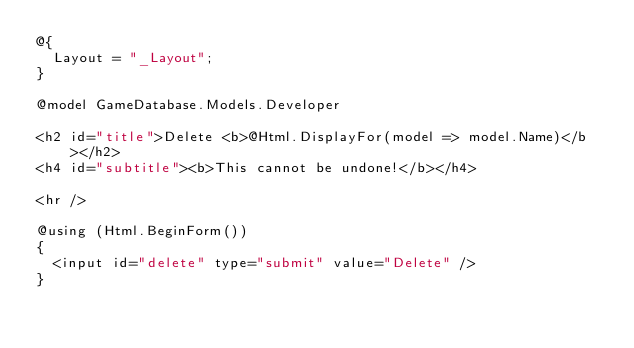<code> <loc_0><loc_0><loc_500><loc_500><_C#_>@{
	Layout = "_Layout";
}

@model GameDatabase.Models.Developer

<h2 id="title">Delete <b>@Html.DisplayFor(model => model.Name)</b></h2>
<h4 id="subtitle"><b>This cannot be undone!</b></h4>

<hr />

@using (Html.BeginForm())
{
	<input id="delete" type="submit" value="Delete" />
}
</code> 